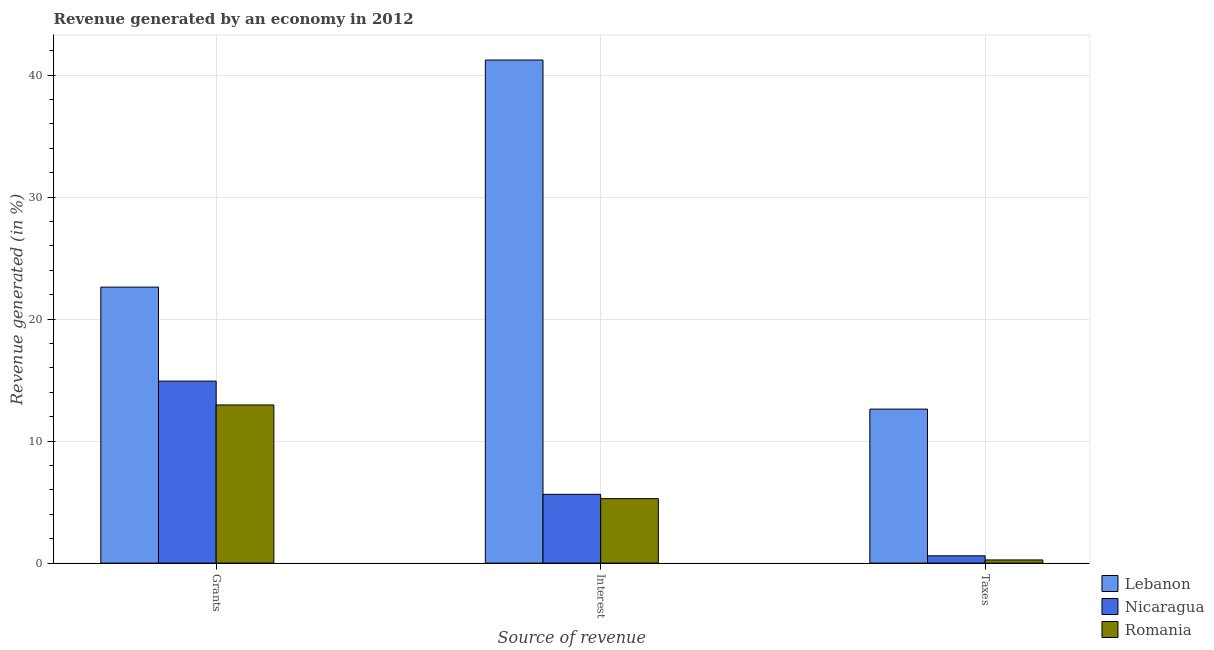How many different coloured bars are there?
Offer a terse response. 3. Are the number of bars per tick equal to the number of legend labels?
Provide a short and direct response. Yes. Are the number of bars on each tick of the X-axis equal?
Make the answer very short. Yes. How many bars are there on the 3rd tick from the left?
Give a very brief answer. 3. How many bars are there on the 3rd tick from the right?
Give a very brief answer. 3. What is the label of the 3rd group of bars from the left?
Your answer should be compact. Taxes. What is the percentage of revenue generated by interest in Lebanon?
Offer a terse response. 41.23. Across all countries, what is the maximum percentage of revenue generated by interest?
Your answer should be compact. 41.23. Across all countries, what is the minimum percentage of revenue generated by taxes?
Offer a very short reply. 0.26. In which country was the percentage of revenue generated by interest maximum?
Ensure brevity in your answer.  Lebanon. In which country was the percentage of revenue generated by grants minimum?
Give a very brief answer. Romania. What is the total percentage of revenue generated by interest in the graph?
Ensure brevity in your answer.  52.15. What is the difference between the percentage of revenue generated by interest in Romania and that in Nicaragua?
Your answer should be compact. -0.35. What is the difference between the percentage of revenue generated by interest in Nicaragua and the percentage of revenue generated by taxes in Romania?
Your response must be concise. 5.38. What is the average percentage of revenue generated by taxes per country?
Ensure brevity in your answer.  4.49. What is the difference between the percentage of revenue generated by interest and percentage of revenue generated by taxes in Nicaragua?
Provide a succinct answer. 5.04. What is the ratio of the percentage of revenue generated by grants in Nicaragua to that in Lebanon?
Make the answer very short. 0.66. Is the percentage of revenue generated by taxes in Nicaragua less than that in Romania?
Keep it short and to the point. No. What is the difference between the highest and the second highest percentage of revenue generated by interest?
Your answer should be compact. 35.6. What is the difference between the highest and the lowest percentage of revenue generated by interest?
Make the answer very short. 35.95. What does the 3rd bar from the left in Interest represents?
Provide a short and direct response. Romania. What does the 3rd bar from the right in Interest represents?
Your answer should be very brief. Lebanon. Is it the case that in every country, the sum of the percentage of revenue generated by grants and percentage of revenue generated by interest is greater than the percentage of revenue generated by taxes?
Offer a very short reply. Yes. How many bars are there?
Give a very brief answer. 9. What is the difference between two consecutive major ticks on the Y-axis?
Offer a very short reply. 10. Are the values on the major ticks of Y-axis written in scientific E-notation?
Provide a succinct answer. No. Does the graph contain grids?
Offer a very short reply. Yes. How many legend labels are there?
Provide a short and direct response. 3. What is the title of the graph?
Ensure brevity in your answer.  Revenue generated by an economy in 2012. What is the label or title of the X-axis?
Provide a short and direct response. Source of revenue. What is the label or title of the Y-axis?
Keep it short and to the point. Revenue generated (in %). What is the Revenue generated (in %) in Lebanon in Grants?
Give a very brief answer. 22.62. What is the Revenue generated (in %) of Nicaragua in Grants?
Your answer should be very brief. 14.92. What is the Revenue generated (in %) of Romania in Grants?
Offer a terse response. 12.96. What is the Revenue generated (in %) in Lebanon in Interest?
Ensure brevity in your answer.  41.23. What is the Revenue generated (in %) in Nicaragua in Interest?
Offer a terse response. 5.64. What is the Revenue generated (in %) of Romania in Interest?
Offer a terse response. 5.28. What is the Revenue generated (in %) in Lebanon in Taxes?
Your response must be concise. 12.62. What is the Revenue generated (in %) of Nicaragua in Taxes?
Ensure brevity in your answer.  0.6. What is the Revenue generated (in %) in Romania in Taxes?
Provide a succinct answer. 0.26. Across all Source of revenue, what is the maximum Revenue generated (in %) in Lebanon?
Your answer should be compact. 41.23. Across all Source of revenue, what is the maximum Revenue generated (in %) of Nicaragua?
Your response must be concise. 14.92. Across all Source of revenue, what is the maximum Revenue generated (in %) in Romania?
Give a very brief answer. 12.96. Across all Source of revenue, what is the minimum Revenue generated (in %) of Lebanon?
Your answer should be compact. 12.62. Across all Source of revenue, what is the minimum Revenue generated (in %) of Nicaragua?
Keep it short and to the point. 0.6. Across all Source of revenue, what is the minimum Revenue generated (in %) of Romania?
Offer a very short reply. 0.26. What is the total Revenue generated (in %) in Lebanon in the graph?
Provide a short and direct response. 76.48. What is the total Revenue generated (in %) of Nicaragua in the graph?
Provide a short and direct response. 21.16. What is the total Revenue generated (in %) in Romania in the graph?
Offer a very short reply. 18.51. What is the difference between the Revenue generated (in %) in Lebanon in Grants and that in Interest?
Ensure brevity in your answer.  -18.61. What is the difference between the Revenue generated (in %) of Nicaragua in Grants and that in Interest?
Make the answer very short. 9.28. What is the difference between the Revenue generated (in %) in Romania in Grants and that in Interest?
Provide a short and direct response. 7.68. What is the difference between the Revenue generated (in %) in Lebanon in Grants and that in Taxes?
Your answer should be very brief. 10. What is the difference between the Revenue generated (in %) of Nicaragua in Grants and that in Taxes?
Offer a terse response. 14.32. What is the difference between the Revenue generated (in %) of Romania in Grants and that in Taxes?
Give a very brief answer. 12.7. What is the difference between the Revenue generated (in %) in Lebanon in Interest and that in Taxes?
Your response must be concise. 28.61. What is the difference between the Revenue generated (in %) in Nicaragua in Interest and that in Taxes?
Keep it short and to the point. 5.04. What is the difference between the Revenue generated (in %) of Romania in Interest and that in Taxes?
Your answer should be compact. 5.02. What is the difference between the Revenue generated (in %) in Lebanon in Grants and the Revenue generated (in %) in Nicaragua in Interest?
Ensure brevity in your answer.  16.98. What is the difference between the Revenue generated (in %) in Lebanon in Grants and the Revenue generated (in %) in Romania in Interest?
Offer a terse response. 17.34. What is the difference between the Revenue generated (in %) of Nicaragua in Grants and the Revenue generated (in %) of Romania in Interest?
Your answer should be compact. 9.63. What is the difference between the Revenue generated (in %) in Lebanon in Grants and the Revenue generated (in %) in Nicaragua in Taxes?
Provide a succinct answer. 22.02. What is the difference between the Revenue generated (in %) of Lebanon in Grants and the Revenue generated (in %) of Romania in Taxes?
Keep it short and to the point. 22.36. What is the difference between the Revenue generated (in %) of Nicaragua in Grants and the Revenue generated (in %) of Romania in Taxes?
Keep it short and to the point. 14.66. What is the difference between the Revenue generated (in %) in Lebanon in Interest and the Revenue generated (in %) in Nicaragua in Taxes?
Offer a terse response. 40.63. What is the difference between the Revenue generated (in %) of Lebanon in Interest and the Revenue generated (in %) of Romania in Taxes?
Make the answer very short. 40.97. What is the difference between the Revenue generated (in %) of Nicaragua in Interest and the Revenue generated (in %) of Romania in Taxes?
Your answer should be very brief. 5.38. What is the average Revenue generated (in %) of Lebanon per Source of revenue?
Your answer should be compact. 25.49. What is the average Revenue generated (in %) of Nicaragua per Source of revenue?
Your response must be concise. 7.05. What is the average Revenue generated (in %) of Romania per Source of revenue?
Provide a short and direct response. 6.17. What is the difference between the Revenue generated (in %) of Lebanon and Revenue generated (in %) of Nicaragua in Grants?
Keep it short and to the point. 7.7. What is the difference between the Revenue generated (in %) in Lebanon and Revenue generated (in %) in Romania in Grants?
Make the answer very short. 9.66. What is the difference between the Revenue generated (in %) of Nicaragua and Revenue generated (in %) of Romania in Grants?
Your answer should be very brief. 1.96. What is the difference between the Revenue generated (in %) of Lebanon and Revenue generated (in %) of Nicaragua in Interest?
Your answer should be very brief. 35.6. What is the difference between the Revenue generated (in %) of Lebanon and Revenue generated (in %) of Romania in Interest?
Provide a short and direct response. 35.95. What is the difference between the Revenue generated (in %) in Nicaragua and Revenue generated (in %) in Romania in Interest?
Keep it short and to the point. 0.35. What is the difference between the Revenue generated (in %) in Lebanon and Revenue generated (in %) in Nicaragua in Taxes?
Ensure brevity in your answer.  12.02. What is the difference between the Revenue generated (in %) in Lebanon and Revenue generated (in %) in Romania in Taxes?
Give a very brief answer. 12.36. What is the difference between the Revenue generated (in %) of Nicaragua and Revenue generated (in %) of Romania in Taxes?
Keep it short and to the point. 0.34. What is the ratio of the Revenue generated (in %) of Lebanon in Grants to that in Interest?
Provide a short and direct response. 0.55. What is the ratio of the Revenue generated (in %) of Nicaragua in Grants to that in Interest?
Your answer should be very brief. 2.65. What is the ratio of the Revenue generated (in %) in Romania in Grants to that in Interest?
Your response must be concise. 2.45. What is the ratio of the Revenue generated (in %) of Lebanon in Grants to that in Taxes?
Your answer should be very brief. 1.79. What is the ratio of the Revenue generated (in %) of Nicaragua in Grants to that in Taxes?
Give a very brief answer. 24.85. What is the ratio of the Revenue generated (in %) in Romania in Grants to that in Taxes?
Offer a terse response. 49.78. What is the ratio of the Revenue generated (in %) in Lebanon in Interest to that in Taxes?
Your answer should be very brief. 3.27. What is the ratio of the Revenue generated (in %) in Nicaragua in Interest to that in Taxes?
Offer a terse response. 9.39. What is the ratio of the Revenue generated (in %) of Romania in Interest to that in Taxes?
Offer a terse response. 20.29. What is the difference between the highest and the second highest Revenue generated (in %) of Lebanon?
Make the answer very short. 18.61. What is the difference between the highest and the second highest Revenue generated (in %) of Nicaragua?
Make the answer very short. 9.28. What is the difference between the highest and the second highest Revenue generated (in %) of Romania?
Provide a short and direct response. 7.68. What is the difference between the highest and the lowest Revenue generated (in %) in Lebanon?
Your answer should be compact. 28.61. What is the difference between the highest and the lowest Revenue generated (in %) in Nicaragua?
Your answer should be very brief. 14.32. What is the difference between the highest and the lowest Revenue generated (in %) of Romania?
Your answer should be very brief. 12.7. 